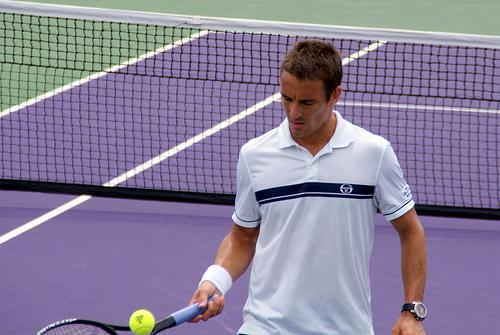For a sportswear advertisement, briefly describe the man's outfit, focusing on distinct features. Showcasing a stylish white shirt with blue stripes and an open collar, paired with a white wristband and black watch, the perfect ensemble for a fashionable tennis player. What prominent accessory is the man wearing on his arm, and what color is it? The man is wearing a white wristband on his arm. For the tennis ball manufacturer's advertisement, describe the ball's appearance and involvement in the ongoing action. Experience unmatched precision and control with our vibrant green tennis ball, captured in motion as it's skillfully played by a focused player on a stunning purple court. Explain the design and color of the racket handle the man is holding. The man is holding a racket with a blue handle and blue grip tape. Describe the color and pattern on the man's shirt in the image. The man is wearing a white shirt with blue stripes and an open collar. Choose a task: What interesting accessory is the man wearing, and specify its color and location. The man is wearing a black watch with a silver face on his wrist. Identify the primary activity happening in the image and the role of the main subject in that activity. A tennis player is holding a racket and preparing to hit a green tennis ball during a match on a purple court. Detail the primary components of the tennis court shown in the image, including colors and markings. The tennis court is purple with white lines, featuring a white tennis net with a black string on it. Imagine you're a tennis coach. Briefly comment on the player's focus and grip on the racket. The tennis player maintains great focus on the ball and has a strong hand grip on the blue racket handle. In the context of the image, describe the tennis ball's appearance and placement. The green tennis ball is positioned above the racket, seemingly in motion to be hit by the tennis player. 